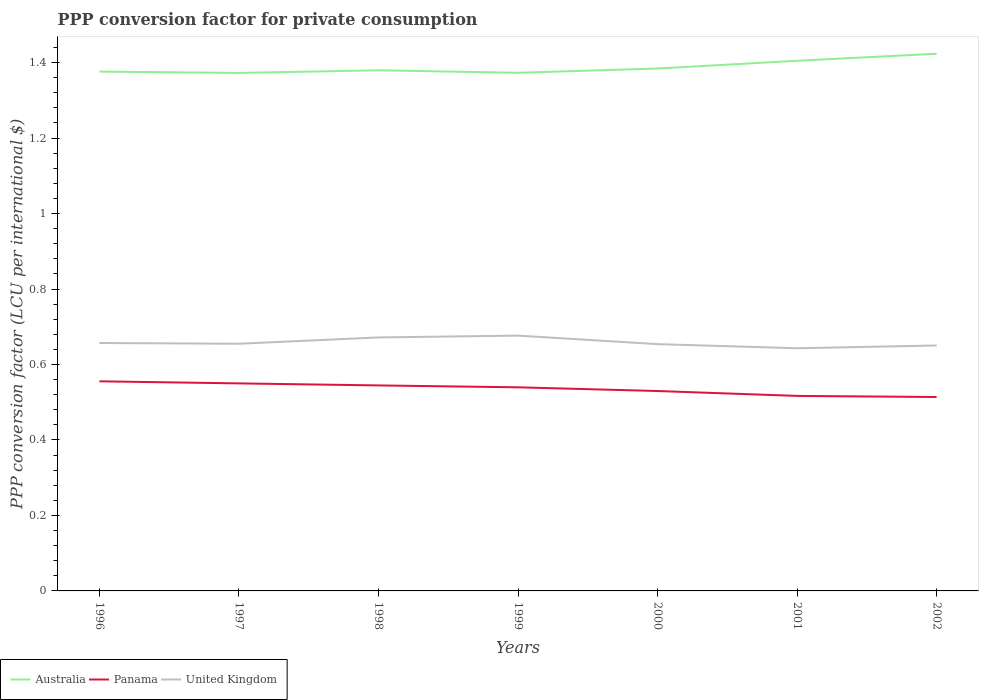Does the line corresponding to Australia intersect with the line corresponding to United Kingdom?
Make the answer very short. No. Is the number of lines equal to the number of legend labels?
Provide a short and direct response. Yes. Across all years, what is the maximum PPP conversion factor for private consumption in United Kingdom?
Give a very brief answer. 0.64. What is the total PPP conversion factor for private consumption in Australia in the graph?
Provide a short and direct response. -0.01. What is the difference between the highest and the second highest PPP conversion factor for private consumption in Australia?
Ensure brevity in your answer.  0.05. What is the difference between the highest and the lowest PPP conversion factor for private consumption in Panama?
Your response must be concise. 4. Is the PPP conversion factor for private consumption in Panama strictly greater than the PPP conversion factor for private consumption in Australia over the years?
Offer a very short reply. Yes. Does the graph contain grids?
Provide a short and direct response. No. What is the title of the graph?
Give a very brief answer. PPP conversion factor for private consumption. What is the label or title of the Y-axis?
Offer a very short reply. PPP conversion factor (LCU per international $). What is the PPP conversion factor (LCU per international $) of Australia in 1996?
Provide a short and direct response. 1.38. What is the PPP conversion factor (LCU per international $) of Panama in 1996?
Give a very brief answer. 0.56. What is the PPP conversion factor (LCU per international $) of United Kingdom in 1996?
Give a very brief answer. 0.66. What is the PPP conversion factor (LCU per international $) of Australia in 1997?
Give a very brief answer. 1.37. What is the PPP conversion factor (LCU per international $) of Panama in 1997?
Your answer should be compact. 0.55. What is the PPP conversion factor (LCU per international $) of United Kingdom in 1997?
Your answer should be compact. 0.65. What is the PPP conversion factor (LCU per international $) in Australia in 1998?
Offer a very short reply. 1.38. What is the PPP conversion factor (LCU per international $) in Panama in 1998?
Provide a short and direct response. 0.54. What is the PPP conversion factor (LCU per international $) in United Kingdom in 1998?
Keep it short and to the point. 0.67. What is the PPP conversion factor (LCU per international $) of Australia in 1999?
Offer a very short reply. 1.37. What is the PPP conversion factor (LCU per international $) of Panama in 1999?
Your response must be concise. 0.54. What is the PPP conversion factor (LCU per international $) in United Kingdom in 1999?
Provide a succinct answer. 0.68. What is the PPP conversion factor (LCU per international $) of Australia in 2000?
Offer a terse response. 1.38. What is the PPP conversion factor (LCU per international $) of Panama in 2000?
Provide a succinct answer. 0.53. What is the PPP conversion factor (LCU per international $) in United Kingdom in 2000?
Give a very brief answer. 0.65. What is the PPP conversion factor (LCU per international $) in Australia in 2001?
Your response must be concise. 1.4. What is the PPP conversion factor (LCU per international $) of Panama in 2001?
Your answer should be compact. 0.52. What is the PPP conversion factor (LCU per international $) in United Kingdom in 2001?
Your answer should be compact. 0.64. What is the PPP conversion factor (LCU per international $) in Australia in 2002?
Offer a terse response. 1.42. What is the PPP conversion factor (LCU per international $) of Panama in 2002?
Keep it short and to the point. 0.51. What is the PPP conversion factor (LCU per international $) in United Kingdom in 2002?
Offer a very short reply. 0.65. Across all years, what is the maximum PPP conversion factor (LCU per international $) in Australia?
Provide a short and direct response. 1.42. Across all years, what is the maximum PPP conversion factor (LCU per international $) in Panama?
Your answer should be very brief. 0.56. Across all years, what is the maximum PPP conversion factor (LCU per international $) of United Kingdom?
Your answer should be very brief. 0.68. Across all years, what is the minimum PPP conversion factor (LCU per international $) of Australia?
Make the answer very short. 1.37. Across all years, what is the minimum PPP conversion factor (LCU per international $) in Panama?
Ensure brevity in your answer.  0.51. Across all years, what is the minimum PPP conversion factor (LCU per international $) of United Kingdom?
Your response must be concise. 0.64. What is the total PPP conversion factor (LCU per international $) of Australia in the graph?
Provide a succinct answer. 9.71. What is the total PPP conversion factor (LCU per international $) in Panama in the graph?
Give a very brief answer. 3.75. What is the total PPP conversion factor (LCU per international $) of United Kingdom in the graph?
Keep it short and to the point. 4.61. What is the difference between the PPP conversion factor (LCU per international $) of Australia in 1996 and that in 1997?
Provide a succinct answer. 0. What is the difference between the PPP conversion factor (LCU per international $) of Panama in 1996 and that in 1997?
Offer a terse response. 0.01. What is the difference between the PPP conversion factor (LCU per international $) in United Kingdom in 1996 and that in 1997?
Give a very brief answer. 0. What is the difference between the PPP conversion factor (LCU per international $) in Australia in 1996 and that in 1998?
Keep it short and to the point. -0. What is the difference between the PPP conversion factor (LCU per international $) in Panama in 1996 and that in 1998?
Keep it short and to the point. 0.01. What is the difference between the PPP conversion factor (LCU per international $) in United Kingdom in 1996 and that in 1998?
Offer a terse response. -0.01. What is the difference between the PPP conversion factor (LCU per international $) of Australia in 1996 and that in 1999?
Provide a short and direct response. 0. What is the difference between the PPP conversion factor (LCU per international $) of Panama in 1996 and that in 1999?
Provide a short and direct response. 0.02. What is the difference between the PPP conversion factor (LCU per international $) in United Kingdom in 1996 and that in 1999?
Give a very brief answer. -0.02. What is the difference between the PPP conversion factor (LCU per international $) in Australia in 1996 and that in 2000?
Offer a very short reply. -0.01. What is the difference between the PPP conversion factor (LCU per international $) in Panama in 1996 and that in 2000?
Your response must be concise. 0.03. What is the difference between the PPP conversion factor (LCU per international $) of United Kingdom in 1996 and that in 2000?
Keep it short and to the point. 0. What is the difference between the PPP conversion factor (LCU per international $) of Australia in 1996 and that in 2001?
Offer a terse response. -0.03. What is the difference between the PPP conversion factor (LCU per international $) in Panama in 1996 and that in 2001?
Provide a succinct answer. 0.04. What is the difference between the PPP conversion factor (LCU per international $) of United Kingdom in 1996 and that in 2001?
Provide a succinct answer. 0.01. What is the difference between the PPP conversion factor (LCU per international $) in Australia in 1996 and that in 2002?
Provide a succinct answer. -0.05. What is the difference between the PPP conversion factor (LCU per international $) of Panama in 1996 and that in 2002?
Offer a very short reply. 0.04. What is the difference between the PPP conversion factor (LCU per international $) in United Kingdom in 1996 and that in 2002?
Offer a terse response. 0.01. What is the difference between the PPP conversion factor (LCU per international $) in Australia in 1997 and that in 1998?
Offer a very short reply. -0.01. What is the difference between the PPP conversion factor (LCU per international $) in Panama in 1997 and that in 1998?
Your answer should be very brief. 0.01. What is the difference between the PPP conversion factor (LCU per international $) in United Kingdom in 1997 and that in 1998?
Give a very brief answer. -0.02. What is the difference between the PPP conversion factor (LCU per international $) of Australia in 1997 and that in 1999?
Give a very brief answer. -0. What is the difference between the PPP conversion factor (LCU per international $) of Panama in 1997 and that in 1999?
Ensure brevity in your answer.  0.01. What is the difference between the PPP conversion factor (LCU per international $) in United Kingdom in 1997 and that in 1999?
Make the answer very short. -0.02. What is the difference between the PPP conversion factor (LCU per international $) in Australia in 1997 and that in 2000?
Offer a terse response. -0.01. What is the difference between the PPP conversion factor (LCU per international $) of Panama in 1997 and that in 2000?
Provide a short and direct response. 0.02. What is the difference between the PPP conversion factor (LCU per international $) of United Kingdom in 1997 and that in 2000?
Offer a terse response. 0. What is the difference between the PPP conversion factor (LCU per international $) in Australia in 1997 and that in 2001?
Offer a very short reply. -0.03. What is the difference between the PPP conversion factor (LCU per international $) in Panama in 1997 and that in 2001?
Make the answer very short. 0.03. What is the difference between the PPP conversion factor (LCU per international $) of United Kingdom in 1997 and that in 2001?
Give a very brief answer. 0.01. What is the difference between the PPP conversion factor (LCU per international $) of Australia in 1997 and that in 2002?
Make the answer very short. -0.05. What is the difference between the PPP conversion factor (LCU per international $) in Panama in 1997 and that in 2002?
Make the answer very short. 0.04. What is the difference between the PPP conversion factor (LCU per international $) of United Kingdom in 1997 and that in 2002?
Your answer should be very brief. 0. What is the difference between the PPP conversion factor (LCU per international $) in Australia in 1998 and that in 1999?
Provide a succinct answer. 0.01. What is the difference between the PPP conversion factor (LCU per international $) in Panama in 1998 and that in 1999?
Keep it short and to the point. 0.01. What is the difference between the PPP conversion factor (LCU per international $) of United Kingdom in 1998 and that in 1999?
Make the answer very short. -0. What is the difference between the PPP conversion factor (LCU per international $) of Australia in 1998 and that in 2000?
Keep it short and to the point. -0. What is the difference between the PPP conversion factor (LCU per international $) in Panama in 1998 and that in 2000?
Keep it short and to the point. 0.01. What is the difference between the PPP conversion factor (LCU per international $) of United Kingdom in 1998 and that in 2000?
Provide a succinct answer. 0.02. What is the difference between the PPP conversion factor (LCU per international $) of Australia in 1998 and that in 2001?
Keep it short and to the point. -0.03. What is the difference between the PPP conversion factor (LCU per international $) of Panama in 1998 and that in 2001?
Your answer should be compact. 0.03. What is the difference between the PPP conversion factor (LCU per international $) of United Kingdom in 1998 and that in 2001?
Make the answer very short. 0.03. What is the difference between the PPP conversion factor (LCU per international $) in Australia in 1998 and that in 2002?
Offer a terse response. -0.04. What is the difference between the PPP conversion factor (LCU per international $) of Panama in 1998 and that in 2002?
Offer a terse response. 0.03. What is the difference between the PPP conversion factor (LCU per international $) in United Kingdom in 1998 and that in 2002?
Your answer should be very brief. 0.02. What is the difference between the PPP conversion factor (LCU per international $) in Australia in 1999 and that in 2000?
Offer a terse response. -0.01. What is the difference between the PPP conversion factor (LCU per international $) in Panama in 1999 and that in 2000?
Provide a short and direct response. 0.01. What is the difference between the PPP conversion factor (LCU per international $) in United Kingdom in 1999 and that in 2000?
Give a very brief answer. 0.02. What is the difference between the PPP conversion factor (LCU per international $) in Australia in 1999 and that in 2001?
Provide a short and direct response. -0.03. What is the difference between the PPP conversion factor (LCU per international $) in Panama in 1999 and that in 2001?
Your response must be concise. 0.02. What is the difference between the PPP conversion factor (LCU per international $) of United Kingdom in 1999 and that in 2001?
Make the answer very short. 0.03. What is the difference between the PPP conversion factor (LCU per international $) in Australia in 1999 and that in 2002?
Give a very brief answer. -0.05. What is the difference between the PPP conversion factor (LCU per international $) of Panama in 1999 and that in 2002?
Your answer should be compact. 0.03. What is the difference between the PPP conversion factor (LCU per international $) in United Kingdom in 1999 and that in 2002?
Keep it short and to the point. 0.03. What is the difference between the PPP conversion factor (LCU per international $) in Australia in 2000 and that in 2001?
Offer a terse response. -0.02. What is the difference between the PPP conversion factor (LCU per international $) in Panama in 2000 and that in 2001?
Your answer should be compact. 0.01. What is the difference between the PPP conversion factor (LCU per international $) in United Kingdom in 2000 and that in 2001?
Offer a terse response. 0.01. What is the difference between the PPP conversion factor (LCU per international $) of Australia in 2000 and that in 2002?
Offer a terse response. -0.04. What is the difference between the PPP conversion factor (LCU per international $) of Panama in 2000 and that in 2002?
Provide a succinct answer. 0.02. What is the difference between the PPP conversion factor (LCU per international $) of United Kingdom in 2000 and that in 2002?
Ensure brevity in your answer.  0. What is the difference between the PPP conversion factor (LCU per international $) in Australia in 2001 and that in 2002?
Keep it short and to the point. -0.02. What is the difference between the PPP conversion factor (LCU per international $) of Panama in 2001 and that in 2002?
Provide a short and direct response. 0. What is the difference between the PPP conversion factor (LCU per international $) in United Kingdom in 2001 and that in 2002?
Provide a short and direct response. -0.01. What is the difference between the PPP conversion factor (LCU per international $) in Australia in 1996 and the PPP conversion factor (LCU per international $) in Panama in 1997?
Your answer should be very brief. 0.83. What is the difference between the PPP conversion factor (LCU per international $) in Australia in 1996 and the PPP conversion factor (LCU per international $) in United Kingdom in 1997?
Offer a terse response. 0.72. What is the difference between the PPP conversion factor (LCU per international $) of Panama in 1996 and the PPP conversion factor (LCU per international $) of United Kingdom in 1997?
Offer a very short reply. -0.1. What is the difference between the PPP conversion factor (LCU per international $) of Australia in 1996 and the PPP conversion factor (LCU per international $) of Panama in 1998?
Offer a very short reply. 0.83. What is the difference between the PPP conversion factor (LCU per international $) of Australia in 1996 and the PPP conversion factor (LCU per international $) of United Kingdom in 1998?
Ensure brevity in your answer.  0.7. What is the difference between the PPP conversion factor (LCU per international $) of Panama in 1996 and the PPP conversion factor (LCU per international $) of United Kingdom in 1998?
Give a very brief answer. -0.12. What is the difference between the PPP conversion factor (LCU per international $) of Australia in 1996 and the PPP conversion factor (LCU per international $) of Panama in 1999?
Provide a succinct answer. 0.84. What is the difference between the PPP conversion factor (LCU per international $) in Australia in 1996 and the PPP conversion factor (LCU per international $) in United Kingdom in 1999?
Provide a short and direct response. 0.7. What is the difference between the PPP conversion factor (LCU per international $) of Panama in 1996 and the PPP conversion factor (LCU per international $) of United Kingdom in 1999?
Provide a short and direct response. -0.12. What is the difference between the PPP conversion factor (LCU per international $) of Australia in 1996 and the PPP conversion factor (LCU per international $) of Panama in 2000?
Give a very brief answer. 0.85. What is the difference between the PPP conversion factor (LCU per international $) in Australia in 1996 and the PPP conversion factor (LCU per international $) in United Kingdom in 2000?
Ensure brevity in your answer.  0.72. What is the difference between the PPP conversion factor (LCU per international $) of Panama in 1996 and the PPP conversion factor (LCU per international $) of United Kingdom in 2000?
Ensure brevity in your answer.  -0.1. What is the difference between the PPP conversion factor (LCU per international $) of Australia in 1996 and the PPP conversion factor (LCU per international $) of Panama in 2001?
Ensure brevity in your answer.  0.86. What is the difference between the PPP conversion factor (LCU per international $) in Australia in 1996 and the PPP conversion factor (LCU per international $) in United Kingdom in 2001?
Offer a very short reply. 0.73. What is the difference between the PPP conversion factor (LCU per international $) in Panama in 1996 and the PPP conversion factor (LCU per international $) in United Kingdom in 2001?
Make the answer very short. -0.09. What is the difference between the PPP conversion factor (LCU per international $) of Australia in 1996 and the PPP conversion factor (LCU per international $) of Panama in 2002?
Provide a succinct answer. 0.86. What is the difference between the PPP conversion factor (LCU per international $) in Australia in 1996 and the PPP conversion factor (LCU per international $) in United Kingdom in 2002?
Your answer should be very brief. 0.73. What is the difference between the PPP conversion factor (LCU per international $) in Panama in 1996 and the PPP conversion factor (LCU per international $) in United Kingdom in 2002?
Your answer should be compact. -0.1. What is the difference between the PPP conversion factor (LCU per international $) in Australia in 1997 and the PPP conversion factor (LCU per international $) in Panama in 1998?
Your response must be concise. 0.83. What is the difference between the PPP conversion factor (LCU per international $) of Australia in 1997 and the PPP conversion factor (LCU per international $) of United Kingdom in 1998?
Your answer should be very brief. 0.7. What is the difference between the PPP conversion factor (LCU per international $) in Panama in 1997 and the PPP conversion factor (LCU per international $) in United Kingdom in 1998?
Provide a short and direct response. -0.12. What is the difference between the PPP conversion factor (LCU per international $) of Australia in 1997 and the PPP conversion factor (LCU per international $) of Panama in 1999?
Make the answer very short. 0.83. What is the difference between the PPP conversion factor (LCU per international $) in Australia in 1997 and the PPP conversion factor (LCU per international $) in United Kingdom in 1999?
Your answer should be compact. 0.7. What is the difference between the PPP conversion factor (LCU per international $) of Panama in 1997 and the PPP conversion factor (LCU per international $) of United Kingdom in 1999?
Your response must be concise. -0.13. What is the difference between the PPP conversion factor (LCU per international $) in Australia in 1997 and the PPP conversion factor (LCU per international $) in Panama in 2000?
Provide a succinct answer. 0.84. What is the difference between the PPP conversion factor (LCU per international $) in Australia in 1997 and the PPP conversion factor (LCU per international $) in United Kingdom in 2000?
Provide a succinct answer. 0.72. What is the difference between the PPP conversion factor (LCU per international $) in Panama in 1997 and the PPP conversion factor (LCU per international $) in United Kingdom in 2000?
Your response must be concise. -0.1. What is the difference between the PPP conversion factor (LCU per international $) of Australia in 1997 and the PPP conversion factor (LCU per international $) of Panama in 2001?
Provide a succinct answer. 0.86. What is the difference between the PPP conversion factor (LCU per international $) in Australia in 1997 and the PPP conversion factor (LCU per international $) in United Kingdom in 2001?
Provide a succinct answer. 0.73. What is the difference between the PPP conversion factor (LCU per international $) of Panama in 1997 and the PPP conversion factor (LCU per international $) of United Kingdom in 2001?
Make the answer very short. -0.09. What is the difference between the PPP conversion factor (LCU per international $) in Australia in 1997 and the PPP conversion factor (LCU per international $) in Panama in 2002?
Your answer should be very brief. 0.86. What is the difference between the PPP conversion factor (LCU per international $) of Australia in 1997 and the PPP conversion factor (LCU per international $) of United Kingdom in 2002?
Your answer should be compact. 0.72. What is the difference between the PPP conversion factor (LCU per international $) in Panama in 1997 and the PPP conversion factor (LCU per international $) in United Kingdom in 2002?
Your answer should be very brief. -0.1. What is the difference between the PPP conversion factor (LCU per international $) in Australia in 1998 and the PPP conversion factor (LCU per international $) in Panama in 1999?
Your answer should be very brief. 0.84. What is the difference between the PPP conversion factor (LCU per international $) of Australia in 1998 and the PPP conversion factor (LCU per international $) of United Kingdom in 1999?
Give a very brief answer. 0.7. What is the difference between the PPP conversion factor (LCU per international $) of Panama in 1998 and the PPP conversion factor (LCU per international $) of United Kingdom in 1999?
Ensure brevity in your answer.  -0.13. What is the difference between the PPP conversion factor (LCU per international $) of Australia in 1998 and the PPP conversion factor (LCU per international $) of Panama in 2000?
Offer a very short reply. 0.85. What is the difference between the PPP conversion factor (LCU per international $) in Australia in 1998 and the PPP conversion factor (LCU per international $) in United Kingdom in 2000?
Your answer should be compact. 0.73. What is the difference between the PPP conversion factor (LCU per international $) of Panama in 1998 and the PPP conversion factor (LCU per international $) of United Kingdom in 2000?
Ensure brevity in your answer.  -0.11. What is the difference between the PPP conversion factor (LCU per international $) in Australia in 1998 and the PPP conversion factor (LCU per international $) in Panama in 2001?
Provide a succinct answer. 0.86. What is the difference between the PPP conversion factor (LCU per international $) of Australia in 1998 and the PPP conversion factor (LCU per international $) of United Kingdom in 2001?
Offer a terse response. 0.74. What is the difference between the PPP conversion factor (LCU per international $) of Panama in 1998 and the PPP conversion factor (LCU per international $) of United Kingdom in 2001?
Your response must be concise. -0.1. What is the difference between the PPP conversion factor (LCU per international $) in Australia in 1998 and the PPP conversion factor (LCU per international $) in Panama in 2002?
Ensure brevity in your answer.  0.87. What is the difference between the PPP conversion factor (LCU per international $) in Australia in 1998 and the PPP conversion factor (LCU per international $) in United Kingdom in 2002?
Provide a short and direct response. 0.73. What is the difference between the PPP conversion factor (LCU per international $) of Panama in 1998 and the PPP conversion factor (LCU per international $) of United Kingdom in 2002?
Your answer should be compact. -0.11. What is the difference between the PPP conversion factor (LCU per international $) of Australia in 1999 and the PPP conversion factor (LCU per international $) of Panama in 2000?
Provide a succinct answer. 0.84. What is the difference between the PPP conversion factor (LCU per international $) of Australia in 1999 and the PPP conversion factor (LCU per international $) of United Kingdom in 2000?
Provide a succinct answer. 0.72. What is the difference between the PPP conversion factor (LCU per international $) in Panama in 1999 and the PPP conversion factor (LCU per international $) in United Kingdom in 2000?
Give a very brief answer. -0.11. What is the difference between the PPP conversion factor (LCU per international $) in Australia in 1999 and the PPP conversion factor (LCU per international $) in Panama in 2001?
Offer a terse response. 0.86. What is the difference between the PPP conversion factor (LCU per international $) of Australia in 1999 and the PPP conversion factor (LCU per international $) of United Kingdom in 2001?
Provide a short and direct response. 0.73. What is the difference between the PPP conversion factor (LCU per international $) in Panama in 1999 and the PPP conversion factor (LCU per international $) in United Kingdom in 2001?
Provide a succinct answer. -0.1. What is the difference between the PPP conversion factor (LCU per international $) in Australia in 1999 and the PPP conversion factor (LCU per international $) in Panama in 2002?
Keep it short and to the point. 0.86. What is the difference between the PPP conversion factor (LCU per international $) in Australia in 1999 and the PPP conversion factor (LCU per international $) in United Kingdom in 2002?
Provide a short and direct response. 0.72. What is the difference between the PPP conversion factor (LCU per international $) of Panama in 1999 and the PPP conversion factor (LCU per international $) of United Kingdom in 2002?
Provide a succinct answer. -0.11. What is the difference between the PPP conversion factor (LCU per international $) of Australia in 2000 and the PPP conversion factor (LCU per international $) of Panama in 2001?
Give a very brief answer. 0.87. What is the difference between the PPP conversion factor (LCU per international $) of Australia in 2000 and the PPP conversion factor (LCU per international $) of United Kingdom in 2001?
Give a very brief answer. 0.74. What is the difference between the PPP conversion factor (LCU per international $) of Panama in 2000 and the PPP conversion factor (LCU per international $) of United Kingdom in 2001?
Provide a short and direct response. -0.11. What is the difference between the PPP conversion factor (LCU per international $) in Australia in 2000 and the PPP conversion factor (LCU per international $) in Panama in 2002?
Make the answer very short. 0.87. What is the difference between the PPP conversion factor (LCU per international $) of Australia in 2000 and the PPP conversion factor (LCU per international $) of United Kingdom in 2002?
Offer a very short reply. 0.73. What is the difference between the PPP conversion factor (LCU per international $) in Panama in 2000 and the PPP conversion factor (LCU per international $) in United Kingdom in 2002?
Make the answer very short. -0.12. What is the difference between the PPP conversion factor (LCU per international $) of Australia in 2001 and the PPP conversion factor (LCU per international $) of Panama in 2002?
Give a very brief answer. 0.89. What is the difference between the PPP conversion factor (LCU per international $) of Australia in 2001 and the PPP conversion factor (LCU per international $) of United Kingdom in 2002?
Your answer should be compact. 0.75. What is the difference between the PPP conversion factor (LCU per international $) of Panama in 2001 and the PPP conversion factor (LCU per international $) of United Kingdom in 2002?
Give a very brief answer. -0.13. What is the average PPP conversion factor (LCU per international $) in Australia per year?
Ensure brevity in your answer.  1.39. What is the average PPP conversion factor (LCU per international $) in Panama per year?
Ensure brevity in your answer.  0.54. What is the average PPP conversion factor (LCU per international $) of United Kingdom per year?
Ensure brevity in your answer.  0.66. In the year 1996, what is the difference between the PPP conversion factor (LCU per international $) in Australia and PPP conversion factor (LCU per international $) in Panama?
Offer a terse response. 0.82. In the year 1996, what is the difference between the PPP conversion factor (LCU per international $) in Australia and PPP conversion factor (LCU per international $) in United Kingdom?
Provide a succinct answer. 0.72. In the year 1996, what is the difference between the PPP conversion factor (LCU per international $) of Panama and PPP conversion factor (LCU per international $) of United Kingdom?
Give a very brief answer. -0.1. In the year 1997, what is the difference between the PPP conversion factor (LCU per international $) in Australia and PPP conversion factor (LCU per international $) in Panama?
Your response must be concise. 0.82. In the year 1997, what is the difference between the PPP conversion factor (LCU per international $) in Australia and PPP conversion factor (LCU per international $) in United Kingdom?
Provide a short and direct response. 0.72. In the year 1997, what is the difference between the PPP conversion factor (LCU per international $) of Panama and PPP conversion factor (LCU per international $) of United Kingdom?
Provide a succinct answer. -0.11. In the year 1998, what is the difference between the PPP conversion factor (LCU per international $) of Australia and PPP conversion factor (LCU per international $) of Panama?
Give a very brief answer. 0.83. In the year 1998, what is the difference between the PPP conversion factor (LCU per international $) in Australia and PPP conversion factor (LCU per international $) in United Kingdom?
Your answer should be compact. 0.71. In the year 1998, what is the difference between the PPP conversion factor (LCU per international $) of Panama and PPP conversion factor (LCU per international $) of United Kingdom?
Provide a succinct answer. -0.13. In the year 1999, what is the difference between the PPP conversion factor (LCU per international $) in Australia and PPP conversion factor (LCU per international $) in Panama?
Your answer should be very brief. 0.83. In the year 1999, what is the difference between the PPP conversion factor (LCU per international $) of Australia and PPP conversion factor (LCU per international $) of United Kingdom?
Your answer should be compact. 0.7. In the year 1999, what is the difference between the PPP conversion factor (LCU per international $) of Panama and PPP conversion factor (LCU per international $) of United Kingdom?
Ensure brevity in your answer.  -0.14. In the year 2000, what is the difference between the PPP conversion factor (LCU per international $) of Australia and PPP conversion factor (LCU per international $) of Panama?
Provide a succinct answer. 0.85. In the year 2000, what is the difference between the PPP conversion factor (LCU per international $) in Australia and PPP conversion factor (LCU per international $) in United Kingdom?
Offer a terse response. 0.73. In the year 2000, what is the difference between the PPP conversion factor (LCU per international $) of Panama and PPP conversion factor (LCU per international $) of United Kingdom?
Give a very brief answer. -0.12. In the year 2001, what is the difference between the PPP conversion factor (LCU per international $) of Australia and PPP conversion factor (LCU per international $) of Panama?
Make the answer very short. 0.89. In the year 2001, what is the difference between the PPP conversion factor (LCU per international $) of Australia and PPP conversion factor (LCU per international $) of United Kingdom?
Ensure brevity in your answer.  0.76. In the year 2001, what is the difference between the PPP conversion factor (LCU per international $) of Panama and PPP conversion factor (LCU per international $) of United Kingdom?
Offer a terse response. -0.13. In the year 2002, what is the difference between the PPP conversion factor (LCU per international $) of Australia and PPP conversion factor (LCU per international $) of Panama?
Your answer should be very brief. 0.91. In the year 2002, what is the difference between the PPP conversion factor (LCU per international $) in Australia and PPP conversion factor (LCU per international $) in United Kingdom?
Make the answer very short. 0.77. In the year 2002, what is the difference between the PPP conversion factor (LCU per international $) in Panama and PPP conversion factor (LCU per international $) in United Kingdom?
Ensure brevity in your answer.  -0.14. What is the ratio of the PPP conversion factor (LCU per international $) in United Kingdom in 1996 to that in 1997?
Keep it short and to the point. 1. What is the ratio of the PPP conversion factor (LCU per international $) in Panama in 1996 to that in 1998?
Give a very brief answer. 1.02. What is the ratio of the PPP conversion factor (LCU per international $) in United Kingdom in 1996 to that in 1998?
Your response must be concise. 0.98. What is the ratio of the PPP conversion factor (LCU per international $) of Australia in 1996 to that in 1999?
Keep it short and to the point. 1. What is the ratio of the PPP conversion factor (LCU per international $) in Panama in 1996 to that in 1999?
Your answer should be very brief. 1.03. What is the ratio of the PPP conversion factor (LCU per international $) in United Kingdom in 1996 to that in 1999?
Your response must be concise. 0.97. What is the ratio of the PPP conversion factor (LCU per international $) of Australia in 1996 to that in 2000?
Provide a succinct answer. 0.99. What is the ratio of the PPP conversion factor (LCU per international $) of Panama in 1996 to that in 2000?
Provide a succinct answer. 1.05. What is the ratio of the PPP conversion factor (LCU per international $) in United Kingdom in 1996 to that in 2000?
Your answer should be very brief. 1. What is the ratio of the PPP conversion factor (LCU per international $) in Australia in 1996 to that in 2001?
Offer a very short reply. 0.98. What is the ratio of the PPP conversion factor (LCU per international $) in Panama in 1996 to that in 2001?
Your response must be concise. 1.07. What is the ratio of the PPP conversion factor (LCU per international $) in United Kingdom in 1996 to that in 2001?
Ensure brevity in your answer.  1.02. What is the ratio of the PPP conversion factor (LCU per international $) in Australia in 1996 to that in 2002?
Provide a succinct answer. 0.97. What is the ratio of the PPP conversion factor (LCU per international $) in Panama in 1996 to that in 2002?
Provide a succinct answer. 1.08. What is the ratio of the PPP conversion factor (LCU per international $) in Australia in 1997 to that in 1998?
Ensure brevity in your answer.  0.99. What is the ratio of the PPP conversion factor (LCU per international $) of Panama in 1997 to that in 1998?
Keep it short and to the point. 1.01. What is the ratio of the PPP conversion factor (LCU per international $) in United Kingdom in 1997 to that in 1998?
Offer a terse response. 0.98. What is the ratio of the PPP conversion factor (LCU per international $) of Australia in 1997 to that in 1999?
Ensure brevity in your answer.  1. What is the ratio of the PPP conversion factor (LCU per international $) of Panama in 1997 to that in 1999?
Make the answer very short. 1.02. What is the ratio of the PPP conversion factor (LCU per international $) of United Kingdom in 1997 to that in 1999?
Ensure brevity in your answer.  0.97. What is the ratio of the PPP conversion factor (LCU per international $) of Panama in 1997 to that in 2000?
Offer a terse response. 1.04. What is the ratio of the PPP conversion factor (LCU per international $) in United Kingdom in 1997 to that in 2000?
Your response must be concise. 1. What is the ratio of the PPP conversion factor (LCU per international $) of Australia in 1997 to that in 2001?
Your answer should be very brief. 0.98. What is the ratio of the PPP conversion factor (LCU per international $) in Panama in 1997 to that in 2001?
Give a very brief answer. 1.06. What is the ratio of the PPP conversion factor (LCU per international $) in United Kingdom in 1997 to that in 2001?
Keep it short and to the point. 1.02. What is the ratio of the PPP conversion factor (LCU per international $) in Australia in 1997 to that in 2002?
Your response must be concise. 0.96. What is the ratio of the PPP conversion factor (LCU per international $) of Panama in 1997 to that in 2002?
Your answer should be compact. 1.07. What is the ratio of the PPP conversion factor (LCU per international $) of United Kingdom in 1997 to that in 2002?
Keep it short and to the point. 1.01. What is the ratio of the PPP conversion factor (LCU per international $) in Australia in 1998 to that in 1999?
Give a very brief answer. 1. What is the ratio of the PPP conversion factor (LCU per international $) in Panama in 1998 to that in 1999?
Your response must be concise. 1.01. What is the ratio of the PPP conversion factor (LCU per international $) of United Kingdom in 1998 to that in 1999?
Offer a very short reply. 0.99. What is the ratio of the PPP conversion factor (LCU per international $) of Australia in 1998 to that in 2000?
Your answer should be compact. 1. What is the ratio of the PPP conversion factor (LCU per international $) in Panama in 1998 to that in 2000?
Offer a very short reply. 1.03. What is the ratio of the PPP conversion factor (LCU per international $) of United Kingdom in 1998 to that in 2000?
Your answer should be compact. 1.03. What is the ratio of the PPP conversion factor (LCU per international $) in Australia in 1998 to that in 2001?
Provide a succinct answer. 0.98. What is the ratio of the PPP conversion factor (LCU per international $) in Panama in 1998 to that in 2001?
Your response must be concise. 1.05. What is the ratio of the PPP conversion factor (LCU per international $) in United Kingdom in 1998 to that in 2001?
Offer a very short reply. 1.04. What is the ratio of the PPP conversion factor (LCU per international $) of Australia in 1998 to that in 2002?
Offer a terse response. 0.97. What is the ratio of the PPP conversion factor (LCU per international $) of Panama in 1998 to that in 2002?
Offer a terse response. 1.06. What is the ratio of the PPP conversion factor (LCU per international $) of United Kingdom in 1998 to that in 2002?
Keep it short and to the point. 1.03. What is the ratio of the PPP conversion factor (LCU per international $) of Panama in 1999 to that in 2000?
Make the answer very short. 1.02. What is the ratio of the PPP conversion factor (LCU per international $) in United Kingdom in 1999 to that in 2000?
Offer a very short reply. 1.03. What is the ratio of the PPP conversion factor (LCU per international $) of Australia in 1999 to that in 2001?
Keep it short and to the point. 0.98. What is the ratio of the PPP conversion factor (LCU per international $) of Panama in 1999 to that in 2001?
Your answer should be compact. 1.04. What is the ratio of the PPP conversion factor (LCU per international $) in United Kingdom in 1999 to that in 2001?
Keep it short and to the point. 1.05. What is the ratio of the PPP conversion factor (LCU per international $) in Australia in 1999 to that in 2002?
Provide a short and direct response. 0.96. What is the ratio of the PPP conversion factor (LCU per international $) in Panama in 1999 to that in 2002?
Provide a short and direct response. 1.05. What is the ratio of the PPP conversion factor (LCU per international $) in United Kingdom in 1999 to that in 2002?
Offer a terse response. 1.04. What is the ratio of the PPP conversion factor (LCU per international $) in Australia in 2000 to that in 2001?
Give a very brief answer. 0.99. What is the ratio of the PPP conversion factor (LCU per international $) in Panama in 2000 to that in 2001?
Provide a short and direct response. 1.03. What is the ratio of the PPP conversion factor (LCU per international $) in United Kingdom in 2000 to that in 2001?
Provide a succinct answer. 1.02. What is the ratio of the PPP conversion factor (LCU per international $) of Australia in 2000 to that in 2002?
Give a very brief answer. 0.97. What is the ratio of the PPP conversion factor (LCU per international $) of Panama in 2000 to that in 2002?
Make the answer very short. 1.03. What is the ratio of the PPP conversion factor (LCU per international $) of United Kingdom in 2000 to that in 2002?
Offer a very short reply. 1.01. What is the ratio of the PPP conversion factor (LCU per international $) of Australia in 2001 to that in 2002?
Your answer should be very brief. 0.99. What is the ratio of the PPP conversion factor (LCU per international $) in United Kingdom in 2001 to that in 2002?
Your answer should be compact. 0.99. What is the difference between the highest and the second highest PPP conversion factor (LCU per international $) of Australia?
Your response must be concise. 0.02. What is the difference between the highest and the second highest PPP conversion factor (LCU per international $) in Panama?
Your response must be concise. 0.01. What is the difference between the highest and the second highest PPP conversion factor (LCU per international $) of United Kingdom?
Make the answer very short. 0. What is the difference between the highest and the lowest PPP conversion factor (LCU per international $) in Australia?
Your answer should be very brief. 0.05. What is the difference between the highest and the lowest PPP conversion factor (LCU per international $) of Panama?
Give a very brief answer. 0.04. What is the difference between the highest and the lowest PPP conversion factor (LCU per international $) in United Kingdom?
Offer a terse response. 0.03. 